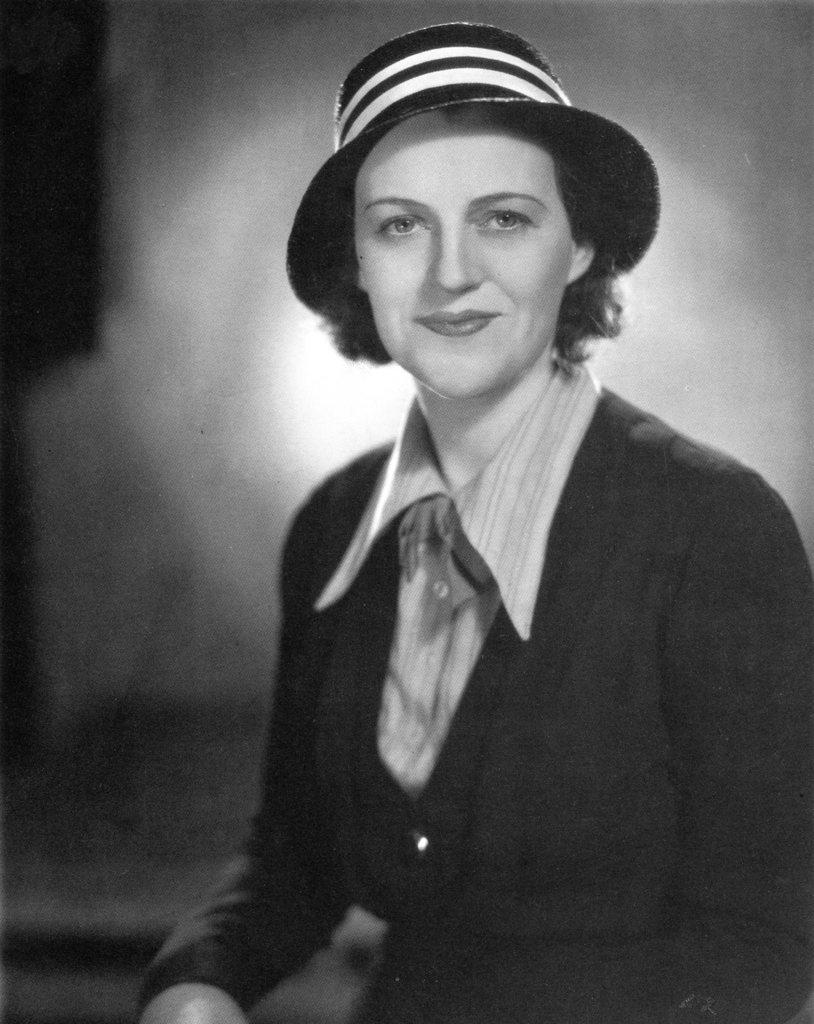What is the color scheme of the picture? The picture is black and white. Who is in the picture? There is a woman in the picture. What is the woman wearing on her head? The woman is wearing a hat. Can you describe the background of the picture? The background of the picture is blurry. What type of bushes can be seen in the picture? There are no bushes present in the picture; it is a black and white image of a woman wearing a hat. How does the woman express her hate in the picture? There is no indication of hate or any emotion in the picture; it only shows a woman wearing a hat in a black and white setting. 